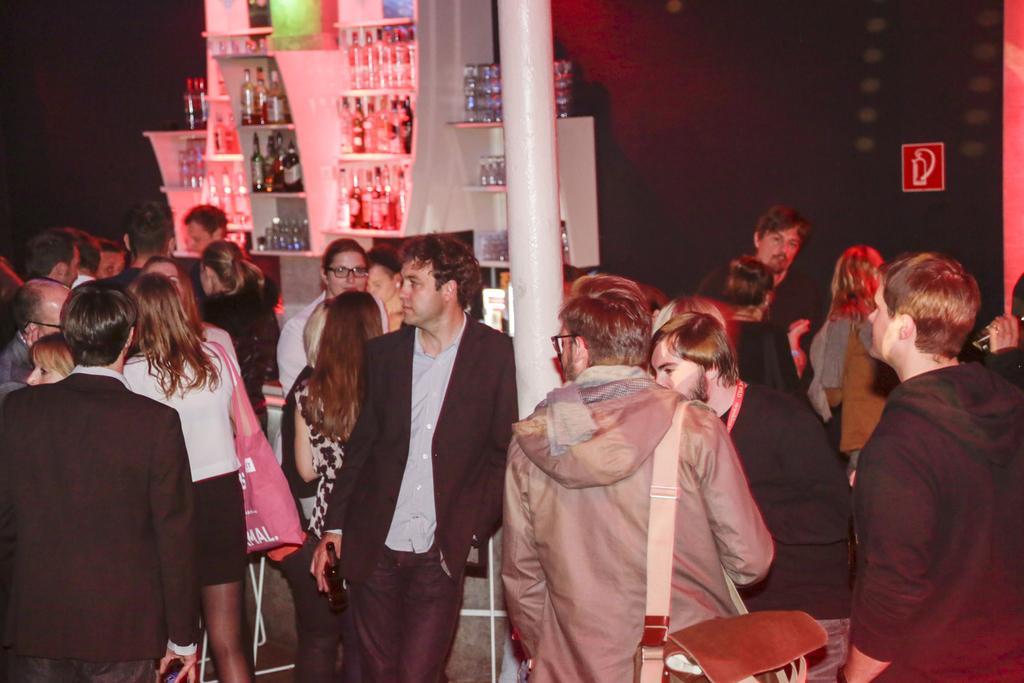Can you describe this image briefly? In this image I see number of people in which this man is holding a bottle in his hand and this man is carrying a bag. In the background I see a sign board over here and on these racks I see number of bottles and I see the pillar over here. 